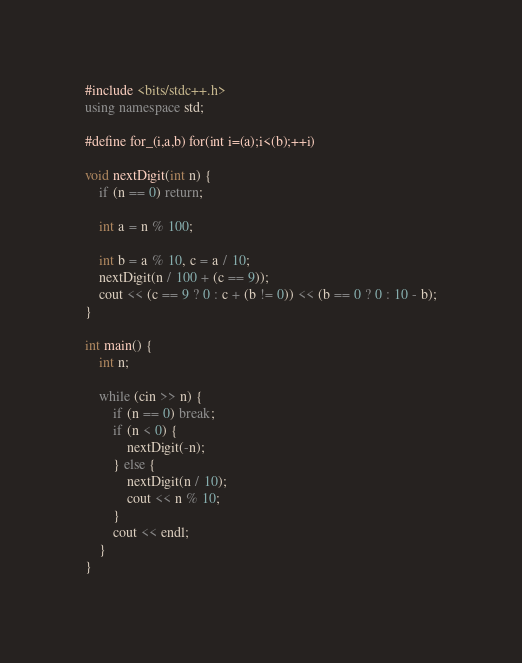Convert code to text. <code><loc_0><loc_0><loc_500><loc_500><_C++_>#include <bits/stdc++.h>
using namespace std;

#define for_(i,a,b) for(int i=(a);i<(b);++i)

void nextDigit(int n) {
	if (n == 0) return;
	
	int a = n % 100;
	
	int b = a % 10, c = a / 10;	
	nextDigit(n / 100 + (c == 9));
	cout << (c == 9 ? 0 : c + (b != 0)) << (b == 0 ? 0 : 10 - b);
}

int main() {
	int n;
	
	while (cin >> n) {
		if (n == 0) break;
		if (n < 0) {
			nextDigit(-n);
		} else {
			nextDigit(n / 10);
			cout << n % 10;
		}
		cout << endl;
	}
}</code> 